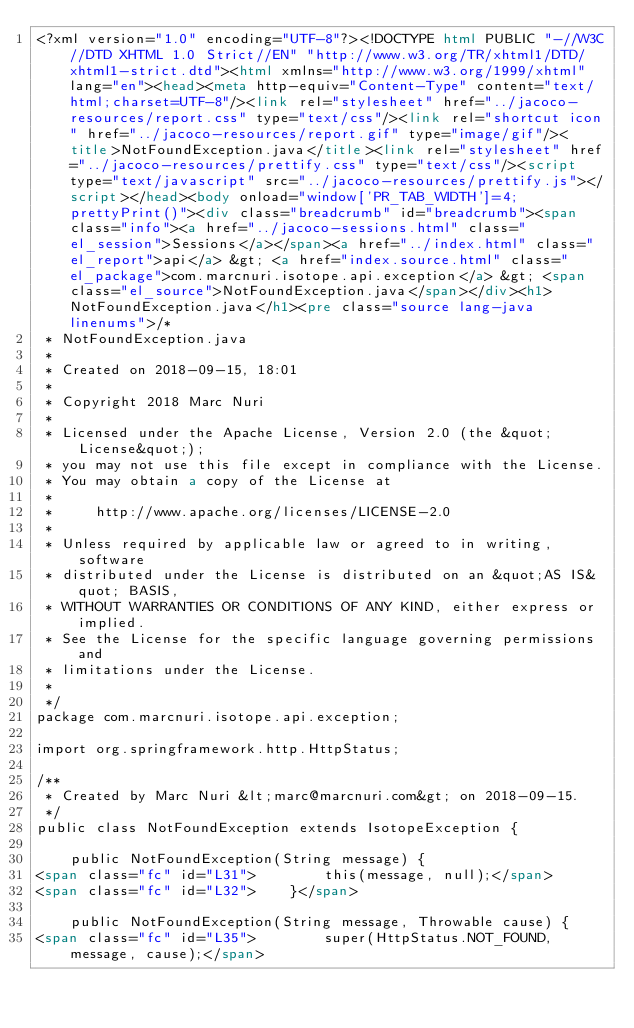<code> <loc_0><loc_0><loc_500><loc_500><_HTML_><?xml version="1.0" encoding="UTF-8"?><!DOCTYPE html PUBLIC "-//W3C//DTD XHTML 1.0 Strict//EN" "http://www.w3.org/TR/xhtml1/DTD/xhtml1-strict.dtd"><html xmlns="http://www.w3.org/1999/xhtml" lang="en"><head><meta http-equiv="Content-Type" content="text/html;charset=UTF-8"/><link rel="stylesheet" href="../jacoco-resources/report.css" type="text/css"/><link rel="shortcut icon" href="../jacoco-resources/report.gif" type="image/gif"/><title>NotFoundException.java</title><link rel="stylesheet" href="../jacoco-resources/prettify.css" type="text/css"/><script type="text/javascript" src="../jacoco-resources/prettify.js"></script></head><body onload="window['PR_TAB_WIDTH']=4;prettyPrint()"><div class="breadcrumb" id="breadcrumb"><span class="info"><a href="../jacoco-sessions.html" class="el_session">Sessions</a></span><a href="../index.html" class="el_report">api</a> &gt; <a href="index.source.html" class="el_package">com.marcnuri.isotope.api.exception</a> &gt; <span class="el_source">NotFoundException.java</span></div><h1>NotFoundException.java</h1><pre class="source lang-java linenums">/*
 * NotFoundException.java
 *
 * Created on 2018-09-15, 18:01
 *
 * Copyright 2018 Marc Nuri
 *
 * Licensed under the Apache License, Version 2.0 (the &quot;License&quot;);
 * you may not use this file except in compliance with the License.
 * You may obtain a copy of the License at
 *
 *     http://www.apache.org/licenses/LICENSE-2.0
 *
 * Unless required by applicable law or agreed to in writing, software
 * distributed under the License is distributed on an &quot;AS IS&quot; BASIS,
 * WITHOUT WARRANTIES OR CONDITIONS OF ANY KIND, either express or implied.
 * See the License for the specific language governing permissions and
 * limitations under the License.
 *
 */
package com.marcnuri.isotope.api.exception;

import org.springframework.http.HttpStatus;

/**
 * Created by Marc Nuri &lt;marc@marcnuri.com&gt; on 2018-09-15.
 */
public class NotFoundException extends IsotopeException {

    public NotFoundException(String message) {
<span class="fc" id="L31">        this(message, null);</span>
<span class="fc" id="L32">    }</span>

    public NotFoundException(String message, Throwable cause) {
<span class="fc" id="L35">        super(HttpStatus.NOT_FOUND, message, cause);</span></code> 